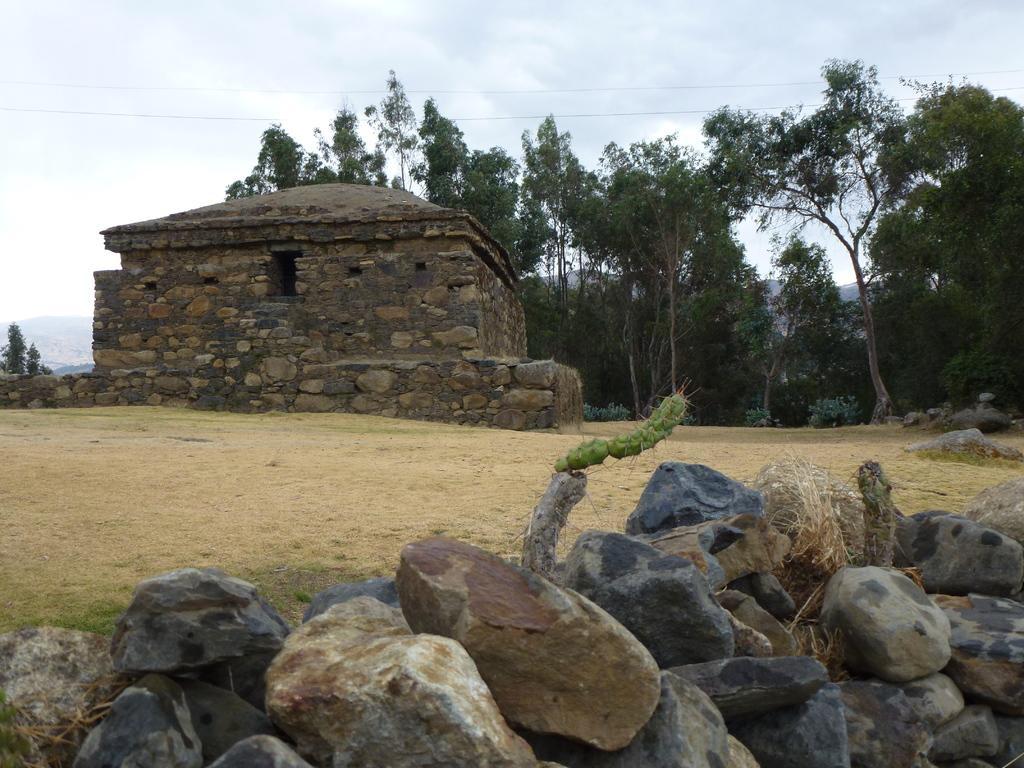Could you give a brief overview of what you see in this image? In this image I can see number of stones and a green colour thing in the front. In the background I can see an open ground, a building, number of trees, mountains, two wires, clouds and the sky. 